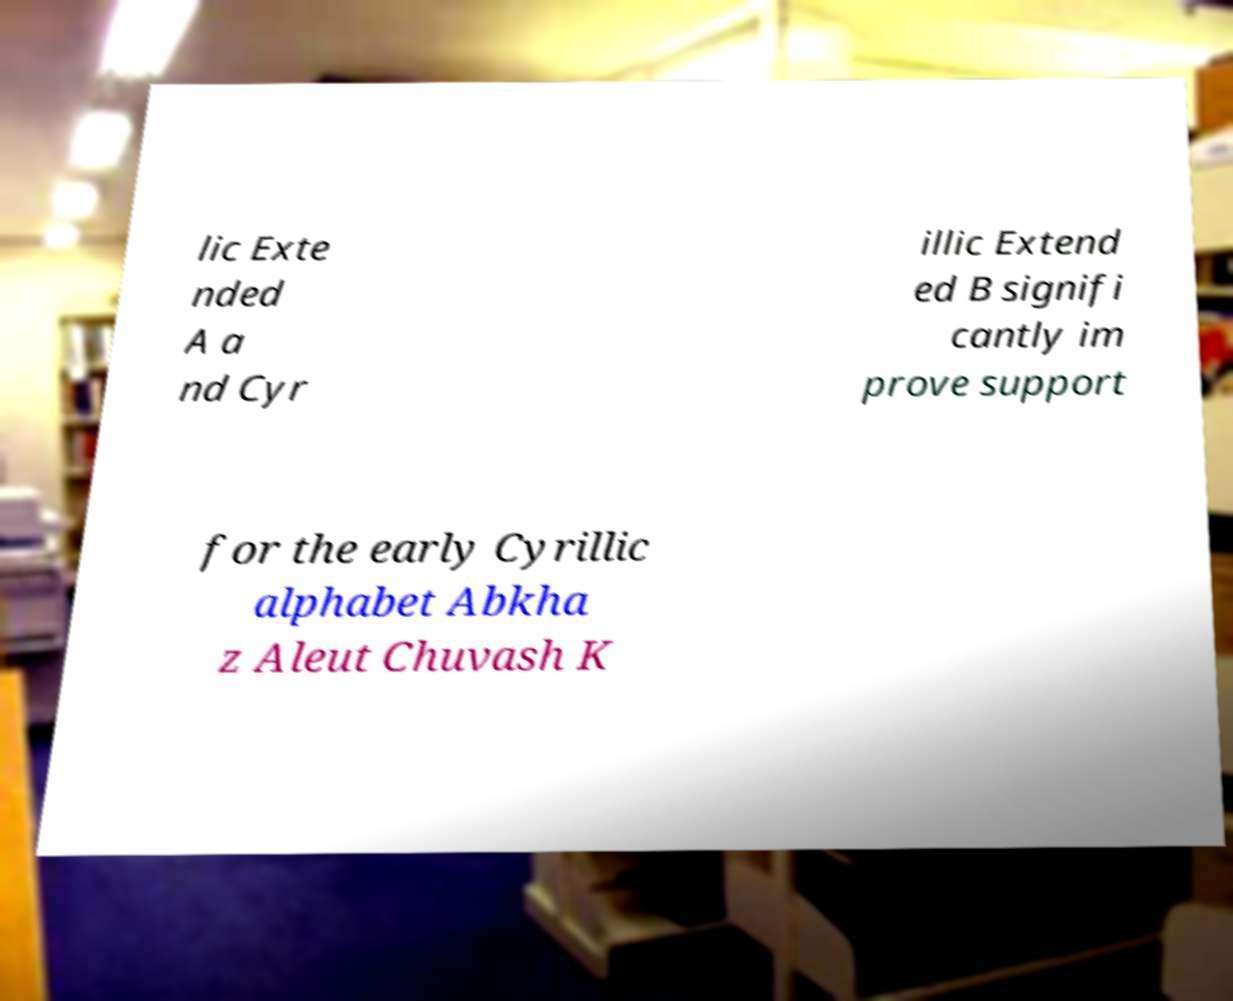Please identify and transcribe the text found in this image. lic Exte nded A a nd Cyr illic Extend ed B signifi cantly im prove support for the early Cyrillic alphabet Abkha z Aleut Chuvash K 